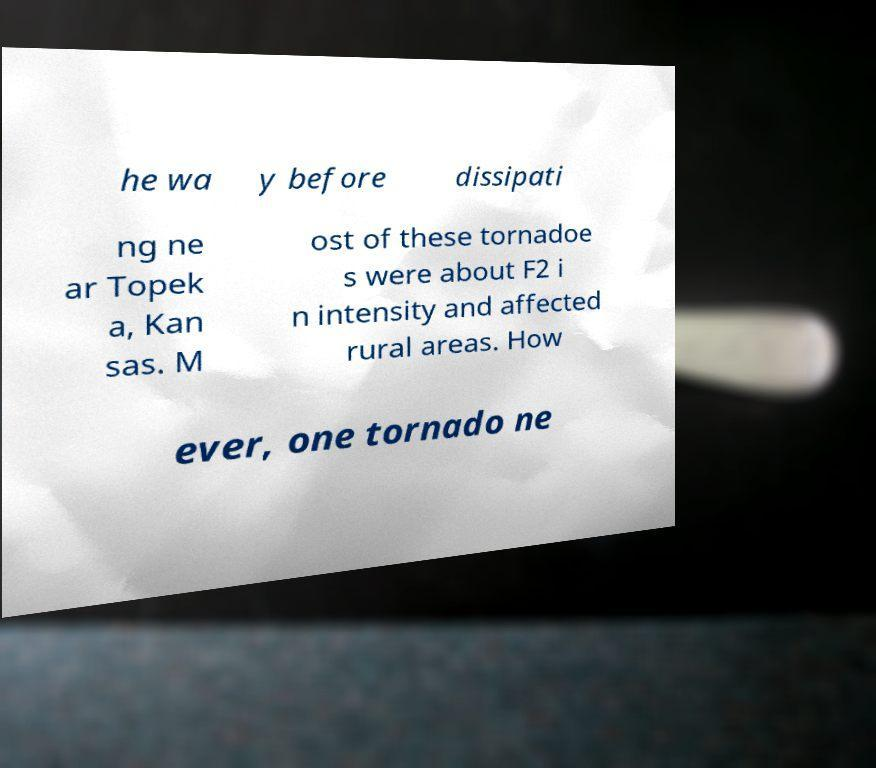Can you accurately transcribe the text from the provided image for me? he wa y before dissipati ng ne ar Topek a, Kan sas. M ost of these tornadoe s were about F2 i n intensity and affected rural areas. How ever, one tornado ne 